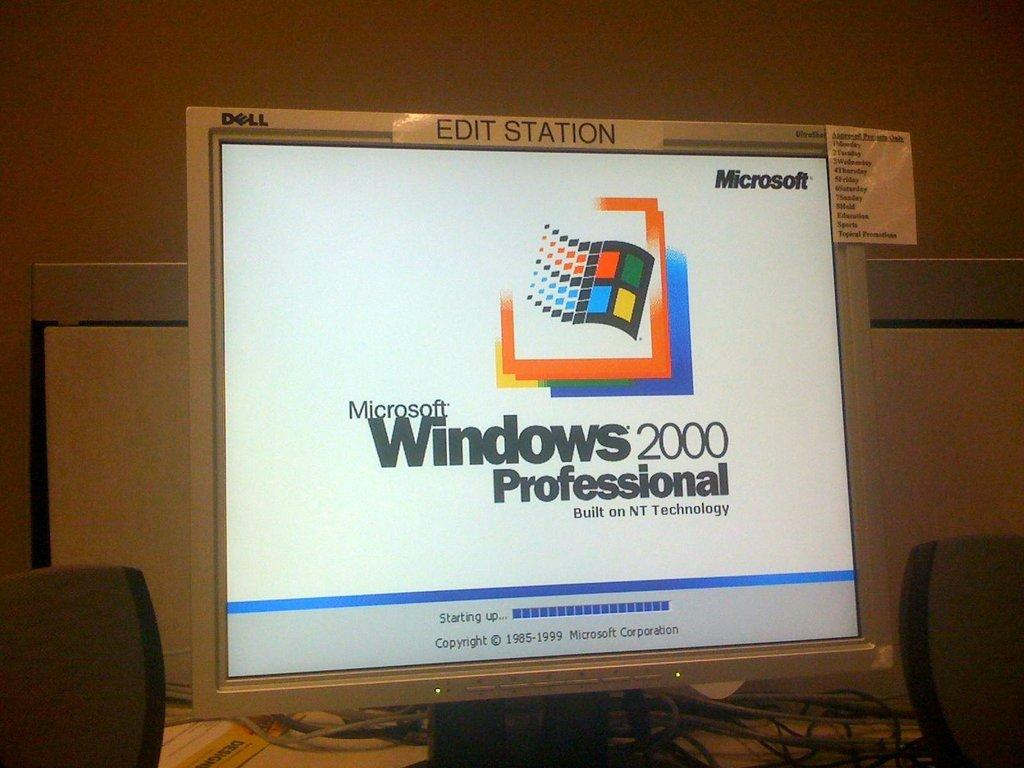<image>
Provide a brief description of the given image. an Edit Station of a Dell computer shows a start up screen 